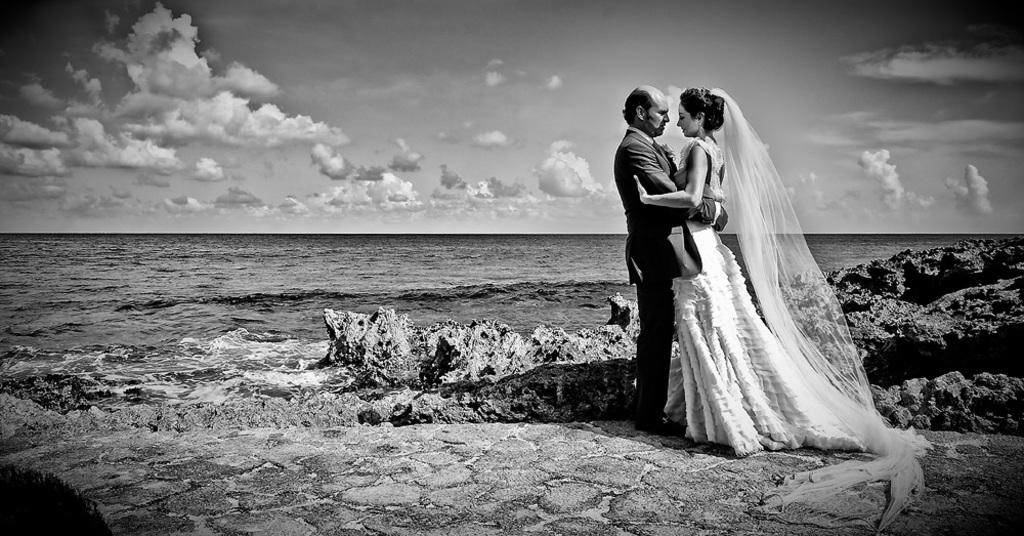What is the color scheme of the image? The image is black and white. Who are the two main subjects in the image? There is a bride and a groom in the image. What can be seen in the sky in the image? There are clouds in the sky in the image. What natural element is visible in the image? There is water visible in the image. What type of geological formation can be seen in the image? There are rocks in the image. What type of scent can be detected in the image? There is no mention of a scent in the image, as it is a visual medium. 